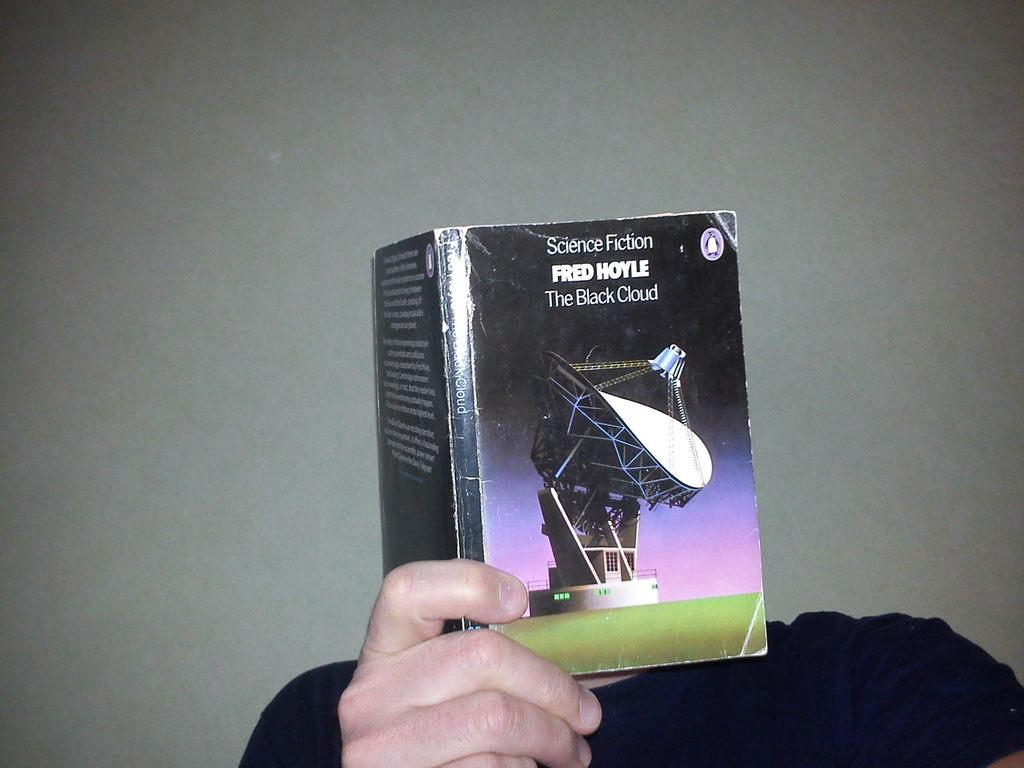Who or what is present in the image? There is a person in the image. What is the person holding? The person is holding a book. What can be seen in the background of the image? There is a wall in the background of the image. What type of cakes are being attacked by the person in the image? There are no cakes or attacks present in the image; it features a person holding a book with a wall in the background. 